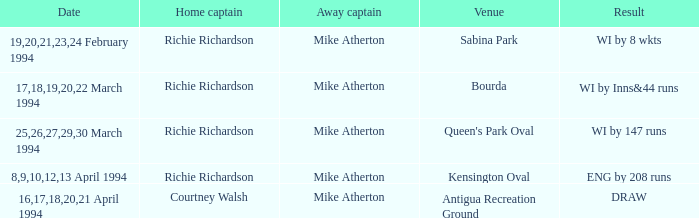Which Home captain has Date of 25,26,27,29,30 march 1994? Richie Richardson. Help me parse the entirety of this table. {'header': ['Date', 'Home captain', 'Away captain', 'Venue', 'Result'], 'rows': [['19,20,21,23,24 February 1994', 'Richie Richardson', 'Mike Atherton', 'Sabina Park', 'WI by 8 wkts'], ['17,18,19,20,22 March 1994', 'Richie Richardson', 'Mike Atherton', 'Bourda', 'WI by Inns&44 runs'], ['25,26,27,29,30 March 1994', 'Richie Richardson', 'Mike Atherton', "Queen's Park Oval", 'WI by 147 runs'], ['8,9,10,12,13 April 1994', 'Richie Richardson', 'Mike Atherton', 'Kensington Oval', 'ENG by 208 runs'], ['16,17,18,20,21 April 1994', 'Courtney Walsh', 'Mike Atherton', 'Antigua Recreation Ground', 'DRAW']]} 